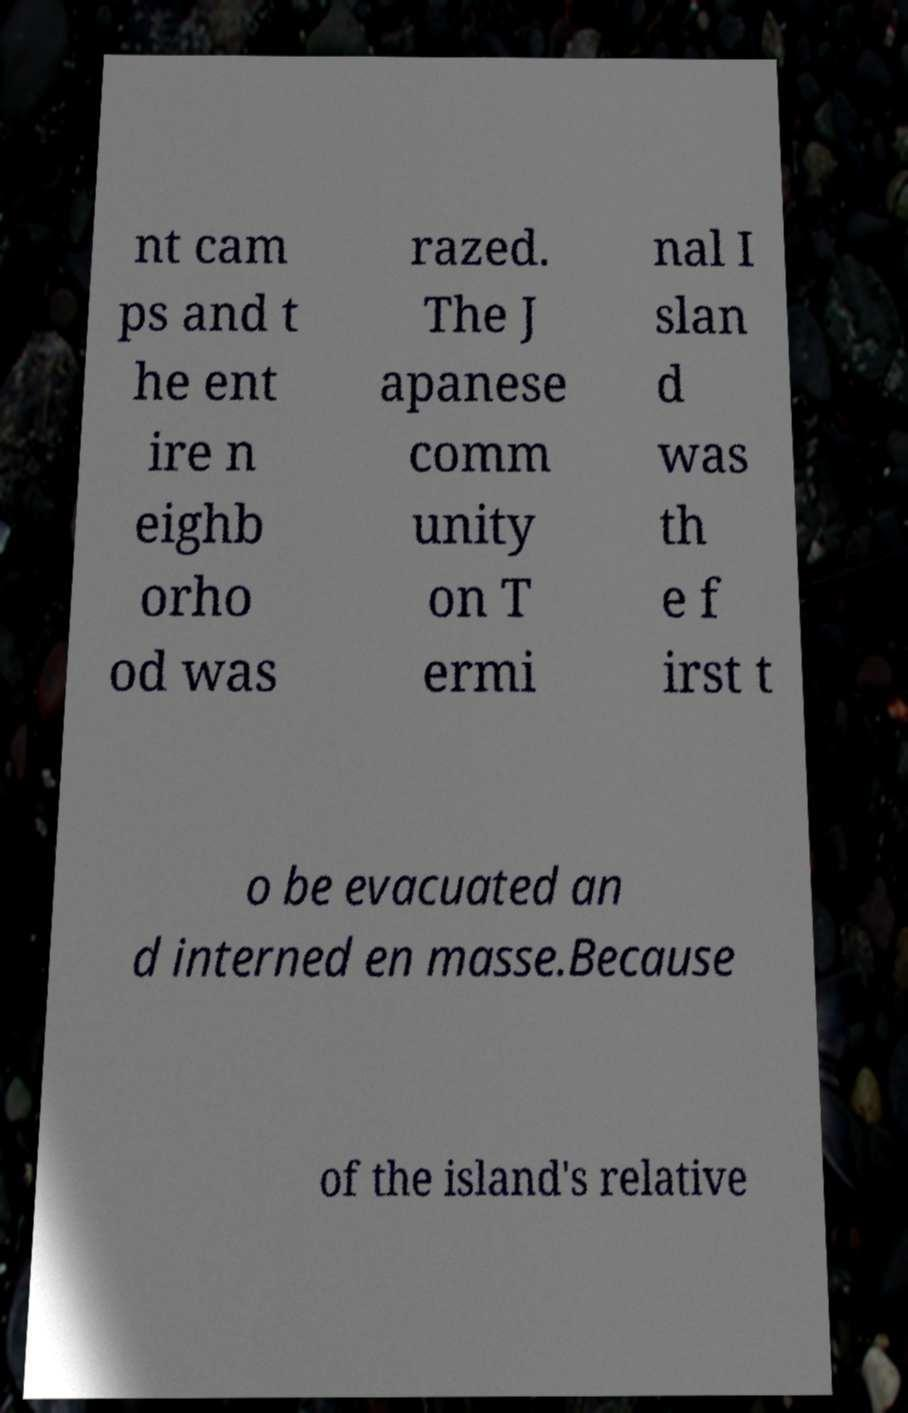Please identify and transcribe the text found in this image. nt cam ps and t he ent ire n eighb orho od was razed. The J apanese comm unity on T ermi nal I slan d was th e f irst t o be evacuated an d interned en masse.Because of the island's relative 